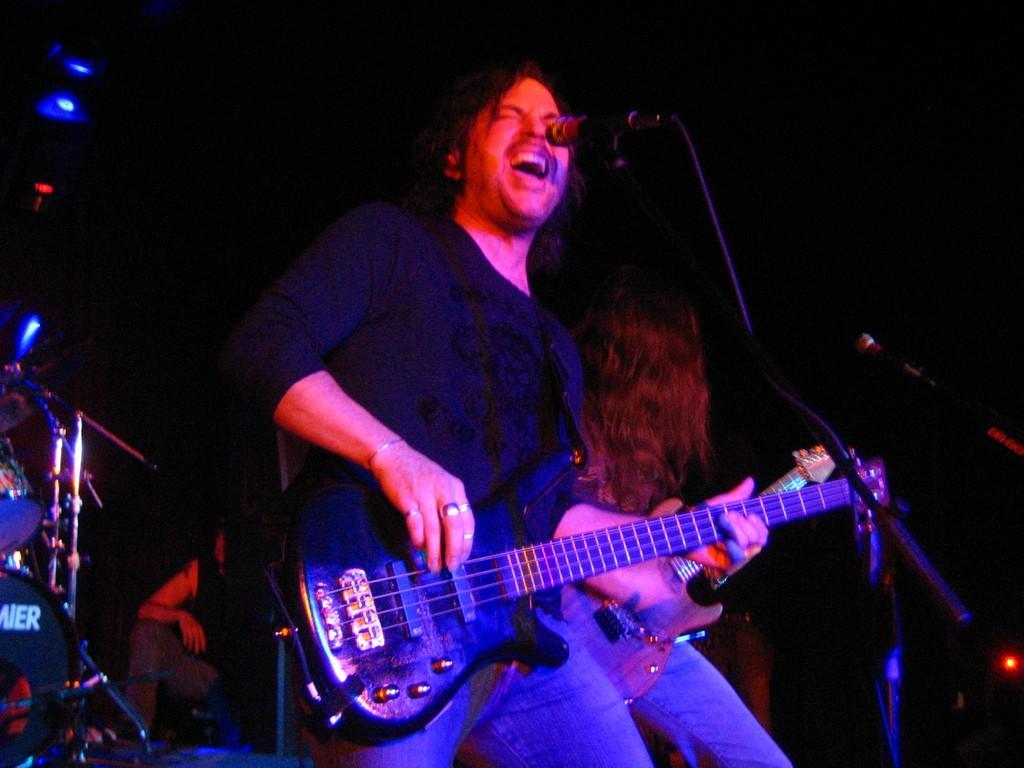Can you describe this image briefly? In this image we can see this person is holding a guitar and playing it. There is a mic in front of him through which he is singing. In the background we can see a woman playing guitar, electronic drums and a person. 